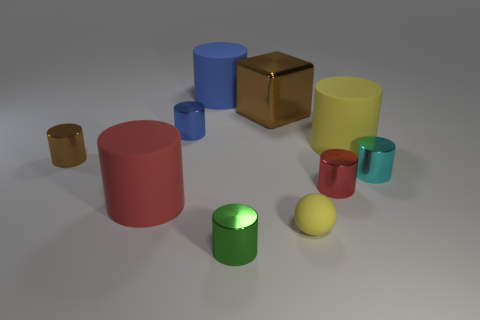Subtract all tiny brown metal cylinders. How many cylinders are left? 7 Subtract 1 spheres. How many spheres are left? 0 Subtract all green cylinders. How many cylinders are left? 7 Subtract all cubes. How many objects are left? 9 Subtract all red cylinders. Subtract all blue balls. How many cylinders are left? 6 Subtract all green spheres. How many green cylinders are left? 1 Subtract all large yellow metallic cylinders. Subtract all cyan objects. How many objects are left? 9 Add 6 brown things. How many brown things are left? 8 Add 6 brown metallic things. How many brown metallic things exist? 8 Subtract 0 red spheres. How many objects are left? 10 